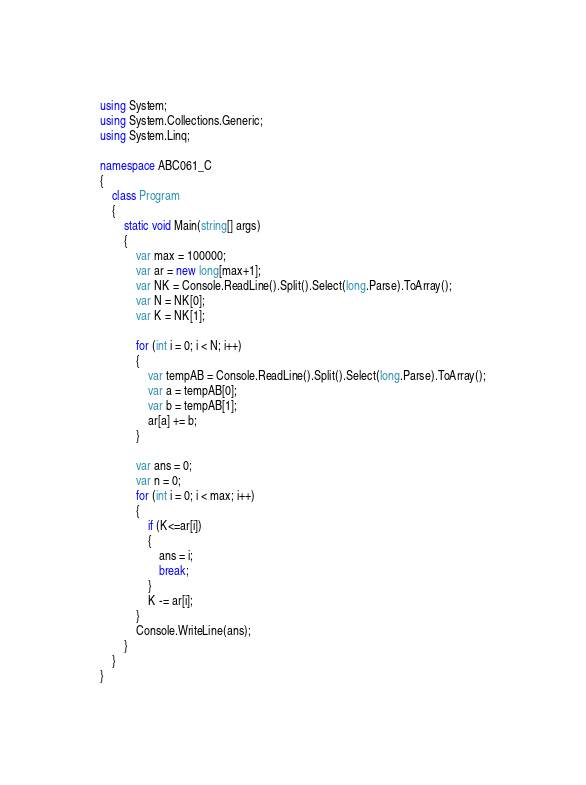Convert code to text. <code><loc_0><loc_0><loc_500><loc_500><_C#_>using System;
using System.Collections.Generic;
using System.Linq;

namespace ABC061_C
{
    class Program
    {
        static void Main(string[] args)
        {
            var max = 100000;
            var ar = new long[max+1];
            var NK = Console.ReadLine().Split().Select(long.Parse).ToArray();
            var N = NK[0];
            var K = NK[1];

            for (int i = 0; i < N; i++)
            {
                var tempAB = Console.ReadLine().Split().Select(long.Parse).ToArray();
                var a = tempAB[0];
                var b = tempAB[1];
                ar[a] += b;
            }

            var ans = 0;
            var n = 0;
            for (int i = 0; i < max; i++)
            {
                if (K<=ar[i])
                {
                    ans = i;
                    break;
                }
                K -= ar[i];
            }
            Console.WriteLine(ans);
        }
    }
}
</code> 